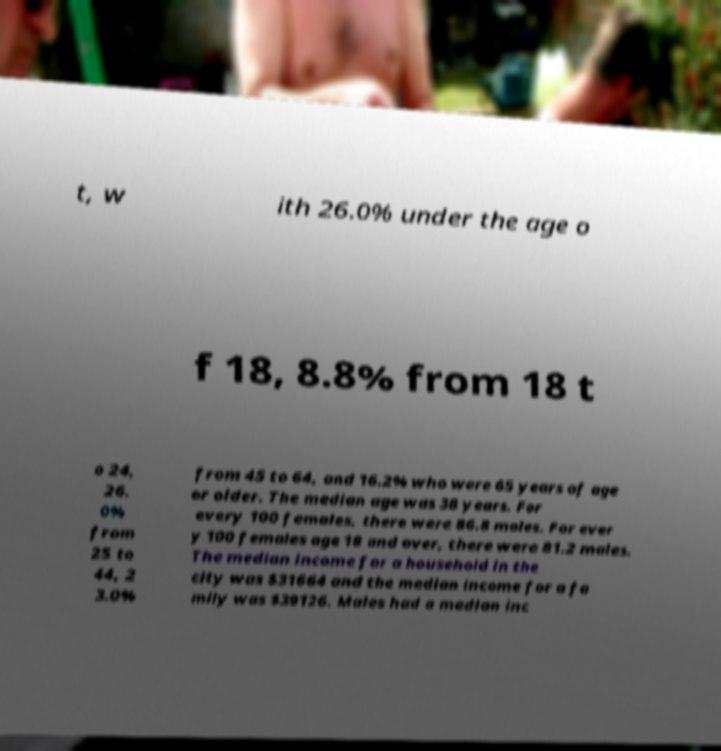I need the written content from this picture converted into text. Can you do that? t, w ith 26.0% under the age o f 18, 8.8% from 18 t o 24, 26. 0% from 25 to 44, 2 3.0% from 45 to 64, and 16.2% who were 65 years of age or older. The median age was 38 years. For every 100 females, there were 86.8 males. For ever y 100 females age 18 and over, there were 81.2 males. The median income for a household in the city was $31664 and the median income for a fa mily was $39126. Males had a median inc 